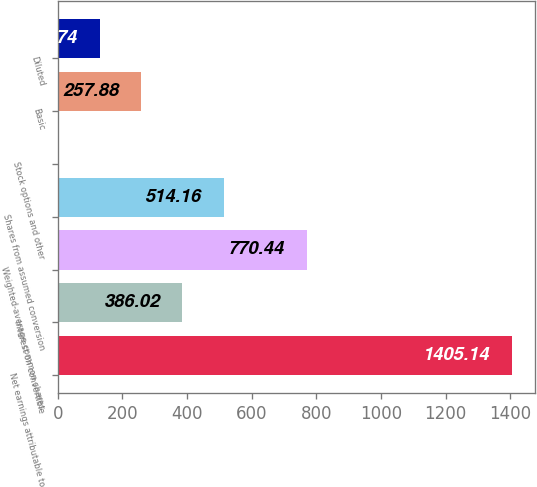Convert chart. <chart><loc_0><loc_0><loc_500><loc_500><bar_chart><fcel>Net earnings attributable to<fcel>Interest on convertible<fcel>Weighted-average common shares<fcel>Shares from assumed conversion<fcel>Stock options and other<fcel>Basic<fcel>Diluted<nl><fcel>1405.14<fcel>386.02<fcel>770.44<fcel>514.16<fcel>1.6<fcel>257.88<fcel>129.74<nl></chart> 